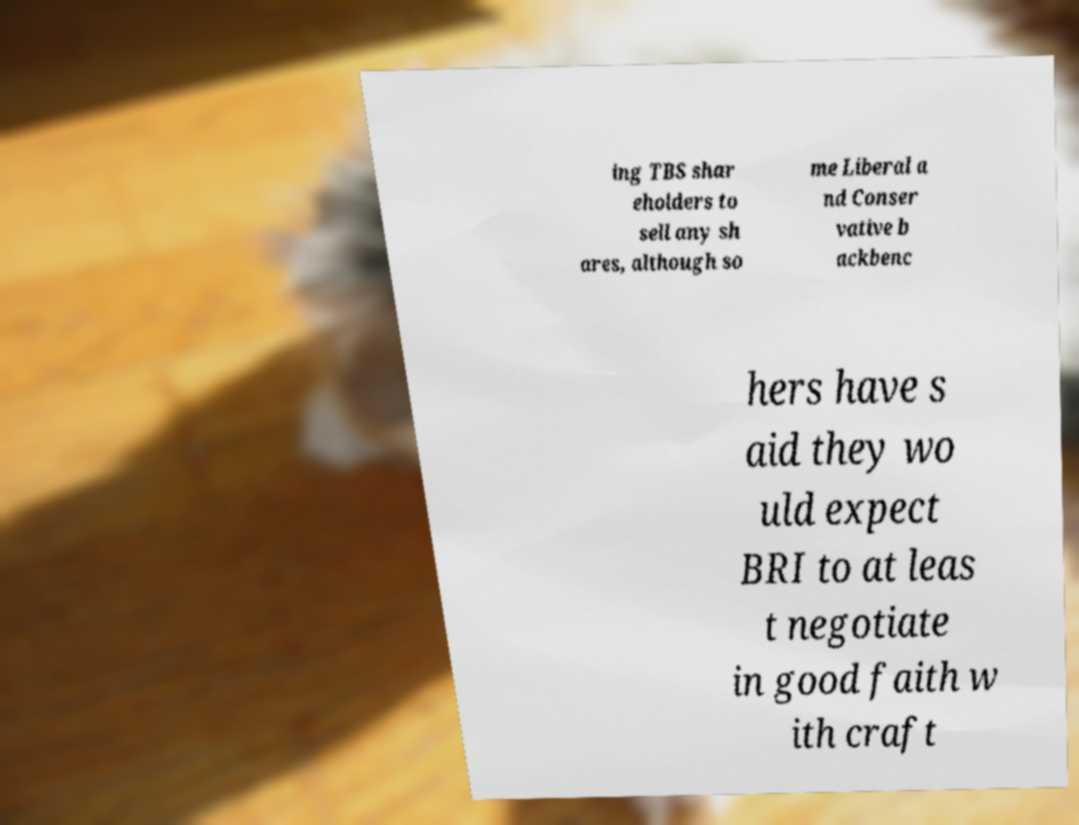Please identify and transcribe the text found in this image. ing TBS shar eholders to sell any sh ares, although so me Liberal a nd Conser vative b ackbenc hers have s aid they wo uld expect BRI to at leas t negotiate in good faith w ith craft 